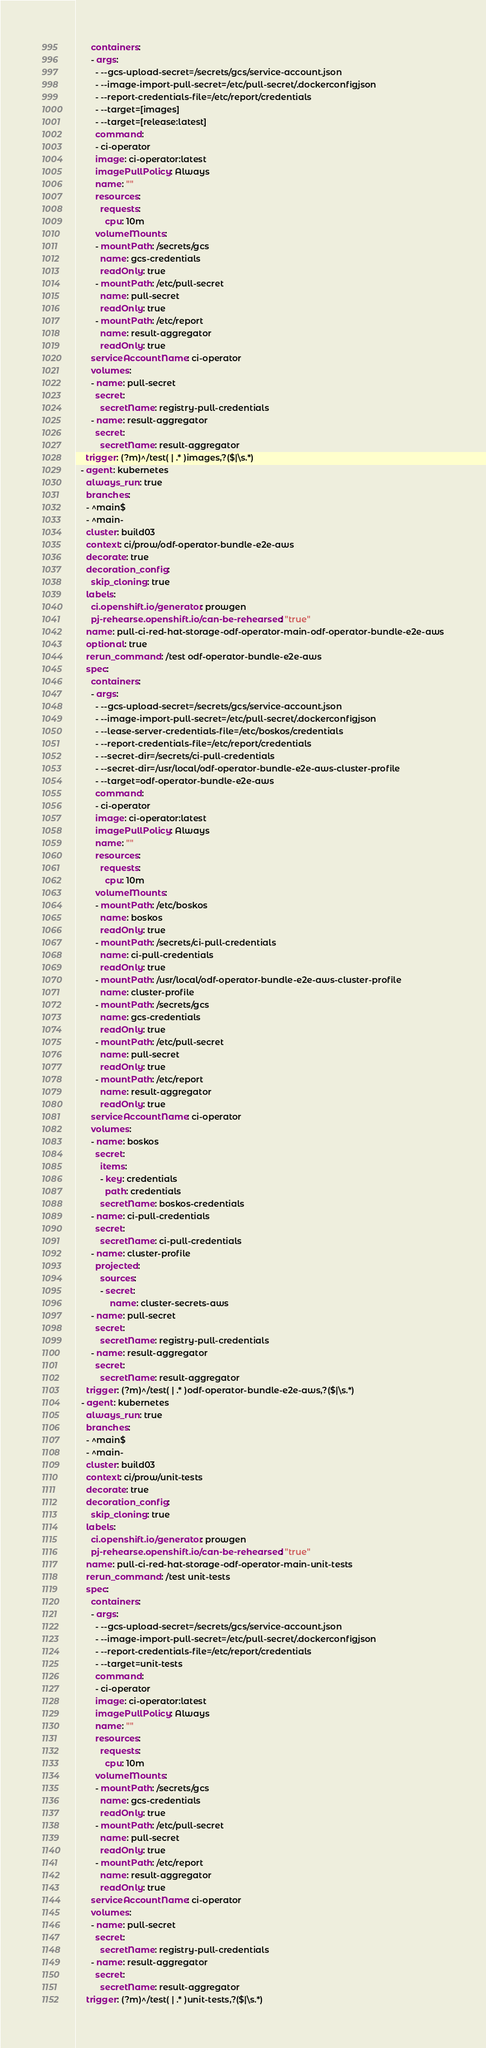Convert code to text. <code><loc_0><loc_0><loc_500><loc_500><_YAML_>      containers:
      - args:
        - --gcs-upload-secret=/secrets/gcs/service-account.json
        - --image-import-pull-secret=/etc/pull-secret/.dockerconfigjson
        - --report-credentials-file=/etc/report/credentials
        - --target=[images]
        - --target=[release:latest]
        command:
        - ci-operator
        image: ci-operator:latest
        imagePullPolicy: Always
        name: ""
        resources:
          requests:
            cpu: 10m
        volumeMounts:
        - mountPath: /secrets/gcs
          name: gcs-credentials
          readOnly: true
        - mountPath: /etc/pull-secret
          name: pull-secret
          readOnly: true
        - mountPath: /etc/report
          name: result-aggregator
          readOnly: true
      serviceAccountName: ci-operator
      volumes:
      - name: pull-secret
        secret:
          secretName: registry-pull-credentials
      - name: result-aggregator
        secret:
          secretName: result-aggregator
    trigger: (?m)^/test( | .* )images,?($|\s.*)
  - agent: kubernetes
    always_run: true
    branches:
    - ^main$
    - ^main-
    cluster: build03
    context: ci/prow/odf-operator-bundle-e2e-aws
    decorate: true
    decoration_config:
      skip_cloning: true
    labels:
      ci.openshift.io/generator: prowgen
      pj-rehearse.openshift.io/can-be-rehearsed: "true"
    name: pull-ci-red-hat-storage-odf-operator-main-odf-operator-bundle-e2e-aws
    optional: true
    rerun_command: /test odf-operator-bundle-e2e-aws
    spec:
      containers:
      - args:
        - --gcs-upload-secret=/secrets/gcs/service-account.json
        - --image-import-pull-secret=/etc/pull-secret/.dockerconfigjson
        - --lease-server-credentials-file=/etc/boskos/credentials
        - --report-credentials-file=/etc/report/credentials
        - --secret-dir=/secrets/ci-pull-credentials
        - --secret-dir=/usr/local/odf-operator-bundle-e2e-aws-cluster-profile
        - --target=odf-operator-bundle-e2e-aws
        command:
        - ci-operator
        image: ci-operator:latest
        imagePullPolicy: Always
        name: ""
        resources:
          requests:
            cpu: 10m
        volumeMounts:
        - mountPath: /etc/boskos
          name: boskos
          readOnly: true
        - mountPath: /secrets/ci-pull-credentials
          name: ci-pull-credentials
          readOnly: true
        - mountPath: /usr/local/odf-operator-bundle-e2e-aws-cluster-profile
          name: cluster-profile
        - mountPath: /secrets/gcs
          name: gcs-credentials
          readOnly: true
        - mountPath: /etc/pull-secret
          name: pull-secret
          readOnly: true
        - mountPath: /etc/report
          name: result-aggregator
          readOnly: true
      serviceAccountName: ci-operator
      volumes:
      - name: boskos
        secret:
          items:
          - key: credentials
            path: credentials
          secretName: boskos-credentials
      - name: ci-pull-credentials
        secret:
          secretName: ci-pull-credentials
      - name: cluster-profile
        projected:
          sources:
          - secret:
              name: cluster-secrets-aws
      - name: pull-secret
        secret:
          secretName: registry-pull-credentials
      - name: result-aggregator
        secret:
          secretName: result-aggregator
    trigger: (?m)^/test( | .* )odf-operator-bundle-e2e-aws,?($|\s.*)
  - agent: kubernetes
    always_run: true
    branches:
    - ^main$
    - ^main-
    cluster: build03
    context: ci/prow/unit-tests
    decorate: true
    decoration_config:
      skip_cloning: true
    labels:
      ci.openshift.io/generator: prowgen
      pj-rehearse.openshift.io/can-be-rehearsed: "true"
    name: pull-ci-red-hat-storage-odf-operator-main-unit-tests
    rerun_command: /test unit-tests
    spec:
      containers:
      - args:
        - --gcs-upload-secret=/secrets/gcs/service-account.json
        - --image-import-pull-secret=/etc/pull-secret/.dockerconfigjson
        - --report-credentials-file=/etc/report/credentials
        - --target=unit-tests
        command:
        - ci-operator
        image: ci-operator:latest
        imagePullPolicy: Always
        name: ""
        resources:
          requests:
            cpu: 10m
        volumeMounts:
        - mountPath: /secrets/gcs
          name: gcs-credentials
          readOnly: true
        - mountPath: /etc/pull-secret
          name: pull-secret
          readOnly: true
        - mountPath: /etc/report
          name: result-aggregator
          readOnly: true
      serviceAccountName: ci-operator
      volumes:
      - name: pull-secret
        secret:
          secretName: registry-pull-credentials
      - name: result-aggregator
        secret:
          secretName: result-aggregator
    trigger: (?m)^/test( | .* )unit-tests,?($|\s.*)
</code> 